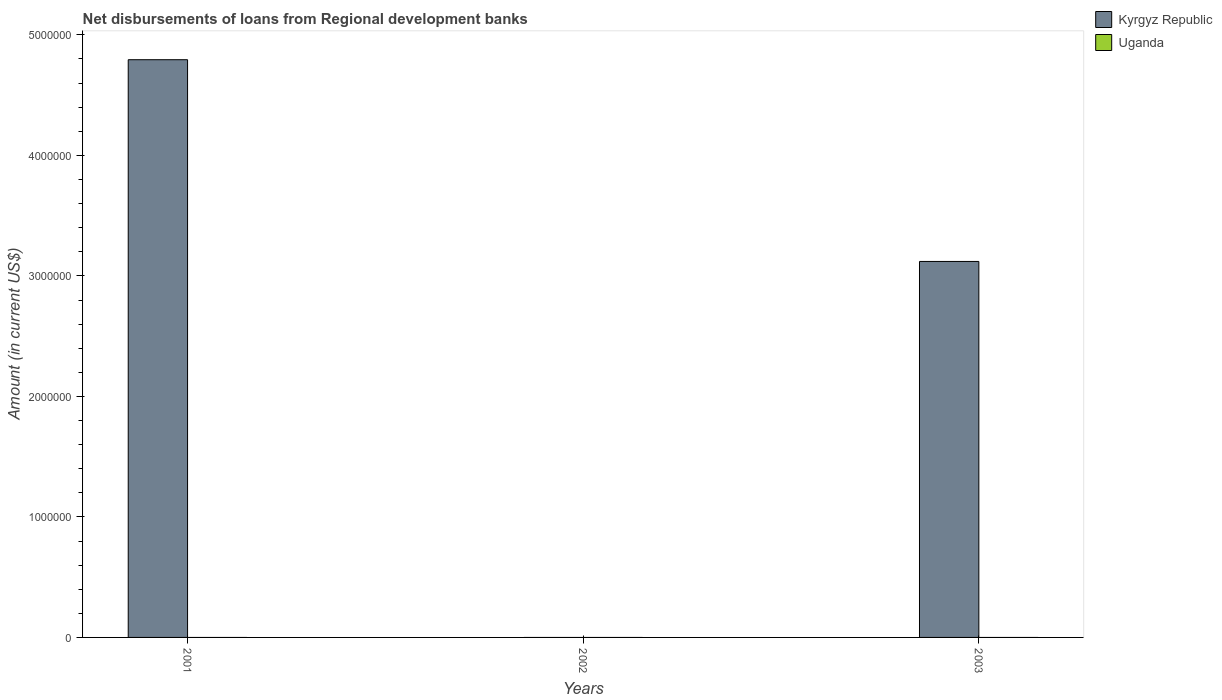How many different coloured bars are there?
Give a very brief answer. 1. Are the number of bars per tick equal to the number of legend labels?
Make the answer very short. No. Are the number of bars on each tick of the X-axis equal?
Keep it short and to the point. No. What is the amount of disbursements of loans from regional development banks in Kyrgyz Republic in 2002?
Give a very brief answer. 0. Across all years, what is the maximum amount of disbursements of loans from regional development banks in Kyrgyz Republic?
Give a very brief answer. 4.79e+06. Across all years, what is the minimum amount of disbursements of loans from regional development banks in Kyrgyz Republic?
Offer a terse response. 0. In which year was the amount of disbursements of loans from regional development banks in Kyrgyz Republic maximum?
Your answer should be compact. 2001. What is the total amount of disbursements of loans from regional development banks in Kyrgyz Republic in the graph?
Offer a very short reply. 7.91e+06. What is the difference between the amount of disbursements of loans from regional development banks in Kyrgyz Republic in 2001 and the amount of disbursements of loans from regional development banks in Uganda in 2002?
Make the answer very short. 4.79e+06. What is the average amount of disbursements of loans from regional development banks in Kyrgyz Republic per year?
Ensure brevity in your answer.  2.64e+06. What is the difference between the highest and the lowest amount of disbursements of loans from regional development banks in Kyrgyz Republic?
Your response must be concise. 4.79e+06. In how many years, is the amount of disbursements of loans from regional development banks in Uganda greater than the average amount of disbursements of loans from regional development banks in Uganda taken over all years?
Provide a succinct answer. 0. Are the values on the major ticks of Y-axis written in scientific E-notation?
Your answer should be very brief. No. Does the graph contain any zero values?
Your answer should be very brief. Yes. Does the graph contain grids?
Provide a succinct answer. No. How many legend labels are there?
Your response must be concise. 2. What is the title of the graph?
Provide a short and direct response. Net disbursements of loans from Regional development banks. Does "Faeroe Islands" appear as one of the legend labels in the graph?
Ensure brevity in your answer.  No. What is the label or title of the X-axis?
Offer a terse response. Years. What is the label or title of the Y-axis?
Give a very brief answer. Amount (in current US$). What is the Amount (in current US$) in Kyrgyz Republic in 2001?
Make the answer very short. 4.79e+06. What is the Amount (in current US$) of Uganda in 2001?
Make the answer very short. 0. What is the Amount (in current US$) of Kyrgyz Republic in 2002?
Your answer should be compact. 0. What is the Amount (in current US$) in Uganda in 2002?
Offer a very short reply. 0. What is the Amount (in current US$) of Kyrgyz Republic in 2003?
Keep it short and to the point. 3.12e+06. Across all years, what is the maximum Amount (in current US$) of Kyrgyz Republic?
Give a very brief answer. 4.79e+06. What is the total Amount (in current US$) in Kyrgyz Republic in the graph?
Make the answer very short. 7.91e+06. What is the total Amount (in current US$) in Uganda in the graph?
Give a very brief answer. 0. What is the difference between the Amount (in current US$) of Kyrgyz Republic in 2001 and that in 2003?
Make the answer very short. 1.67e+06. What is the average Amount (in current US$) of Kyrgyz Republic per year?
Your answer should be very brief. 2.64e+06. What is the ratio of the Amount (in current US$) of Kyrgyz Republic in 2001 to that in 2003?
Your response must be concise. 1.54. What is the difference between the highest and the lowest Amount (in current US$) in Kyrgyz Republic?
Give a very brief answer. 4.79e+06. 